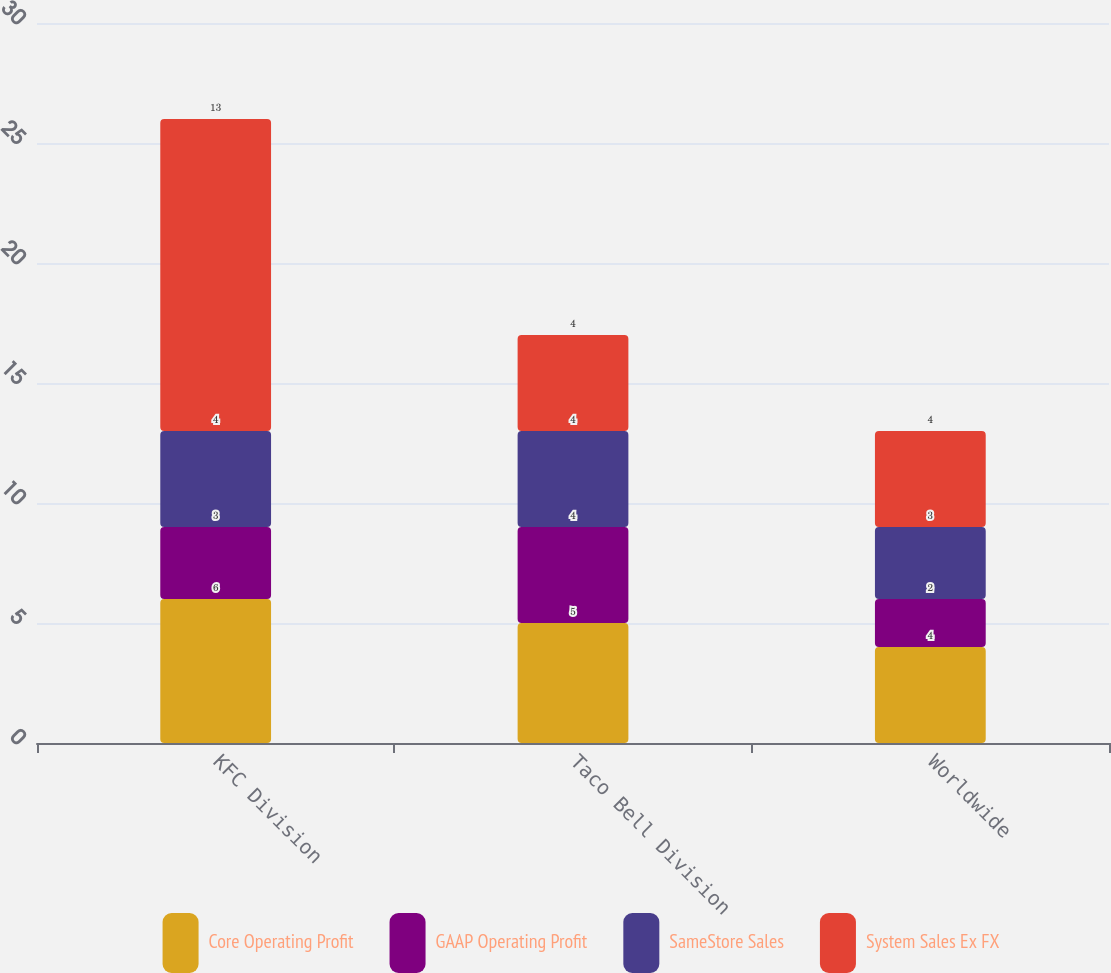<chart> <loc_0><loc_0><loc_500><loc_500><stacked_bar_chart><ecel><fcel>KFC Division<fcel>Taco Bell Division<fcel>Worldwide<nl><fcel>Core Operating Profit<fcel>6<fcel>5<fcel>4<nl><fcel>GAAP Operating Profit<fcel>3<fcel>4<fcel>2<nl><fcel>SameStore Sales<fcel>4<fcel>4<fcel>3<nl><fcel>System Sales Ex FX<fcel>13<fcel>4<fcel>4<nl></chart> 